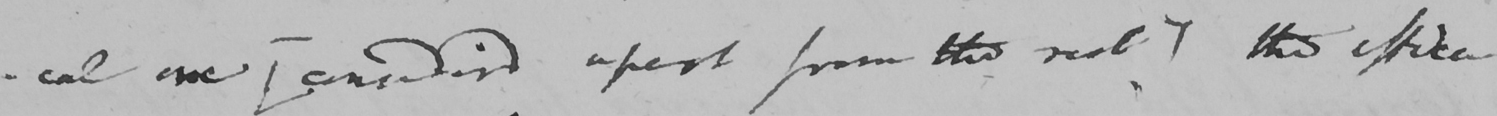What text is written in this handwritten line? -cal one  [ consider ' d apart from the rest ]  tho effica- 